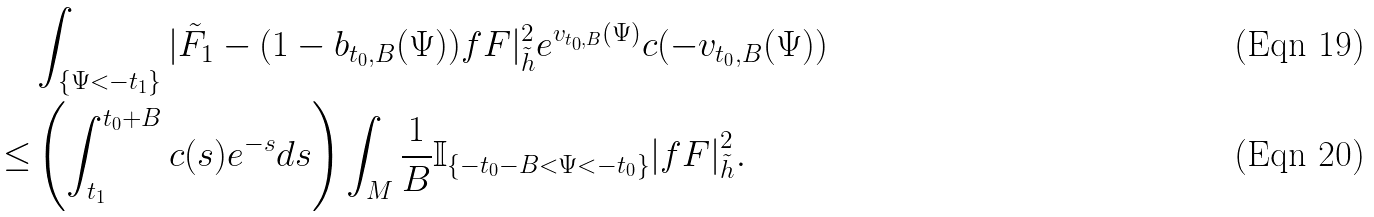<formula> <loc_0><loc_0><loc_500><loc_500>& \int _ { \{ \Psi < - t _ { 1 } \} } | \tilde { F } _ { 1 } - ( 1 - b _ { t _ { 0 } , B } ( \Psi ) ) f F | ^ { 2 } _ { \tilde { h } } e ^ { v _ { t _ { 0 } , B } ( \Psi ) } c ( - v _ { t _ { 0 } , B } ( \Psi ) ) \\ \leq & \left ( \int _ { t _ { 1 } } ^ { t _ { 0 } + B } c ( s ) e ^ { - s } d s \right ) \int _ { M } \frac { 1 } { B } \mathbb { I } _ { \{ - t _ { 0 } - B < \Psi < - t _ { 0 } \} } { | f F | } ^ { 2 } _ { \tilde { h } } .</formula> 